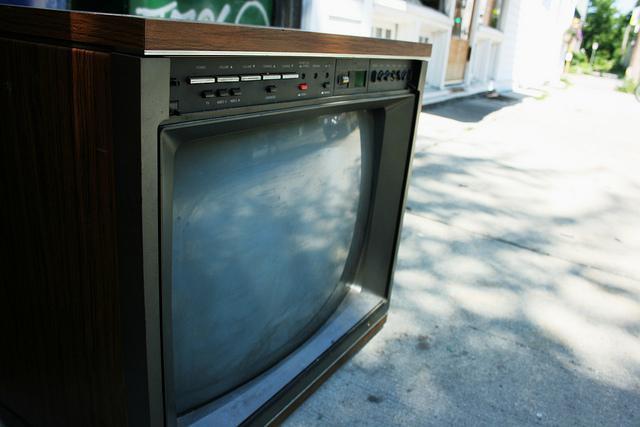How many dogs are there with brown color?
Give a very brief answer. 0. 